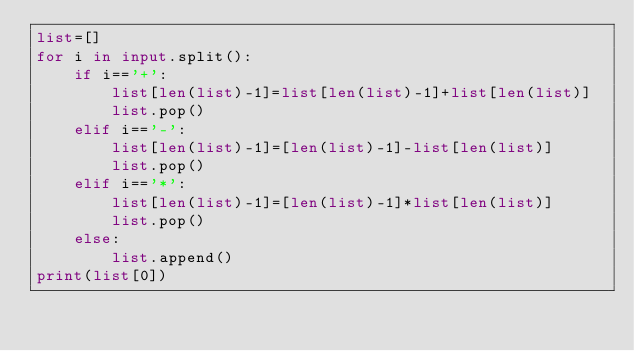<code> <loc_0><loc_0><loc_500><loc_500><_Python_>list=[]
for i in input.split():
    if i=='+':
        list[len(list)-1]=list[len(list)-1]+list[len(list)]
        list.pop()
    elif i=='-':
        list[len(list)-1]=[len(list)-1]-list[len(list)]
        list.pop()
    elif i=='*':
        list[len(list)-1]=[len(list)-1]*list[len(list)]
        list.pop()
    else:
        list.append()
print(list[0])

</code> 